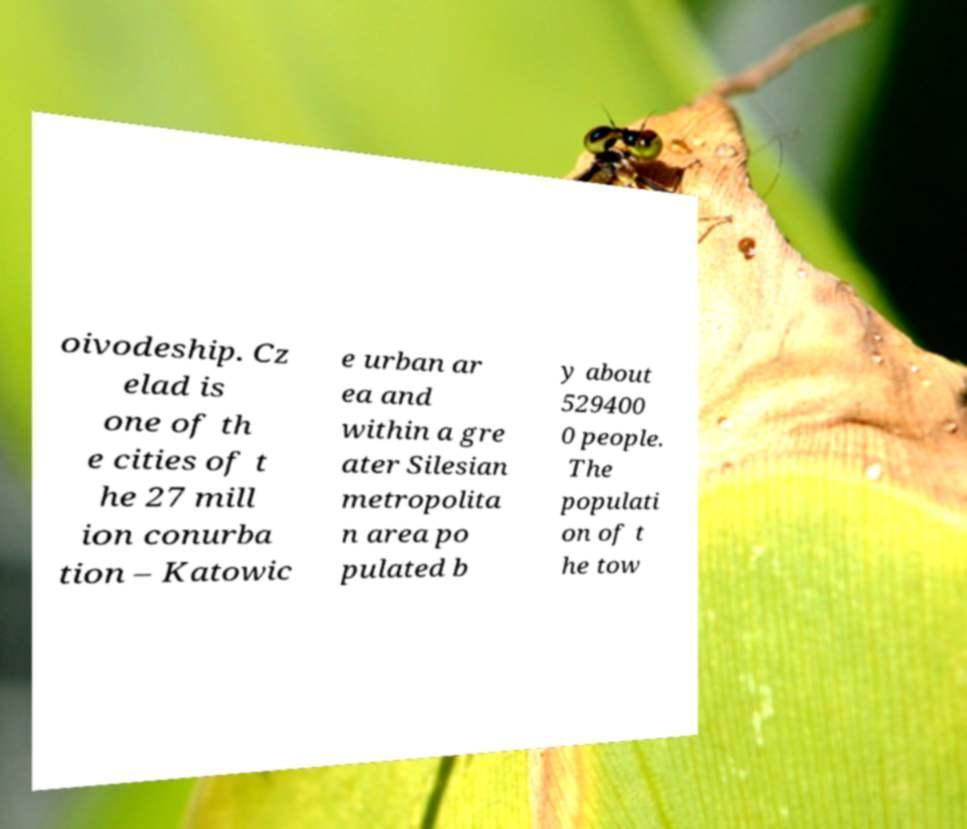Could you assist in decoding the text presented in this image and type it out clearly? oivodeship. Cz elad is one of th e cities of t he 27 mill ion conurba tion – Katowic e urban ar ea and within a gre ater Silesian metropolita n area po pulated b y about 529400 0 people. The populati on of t he tow 